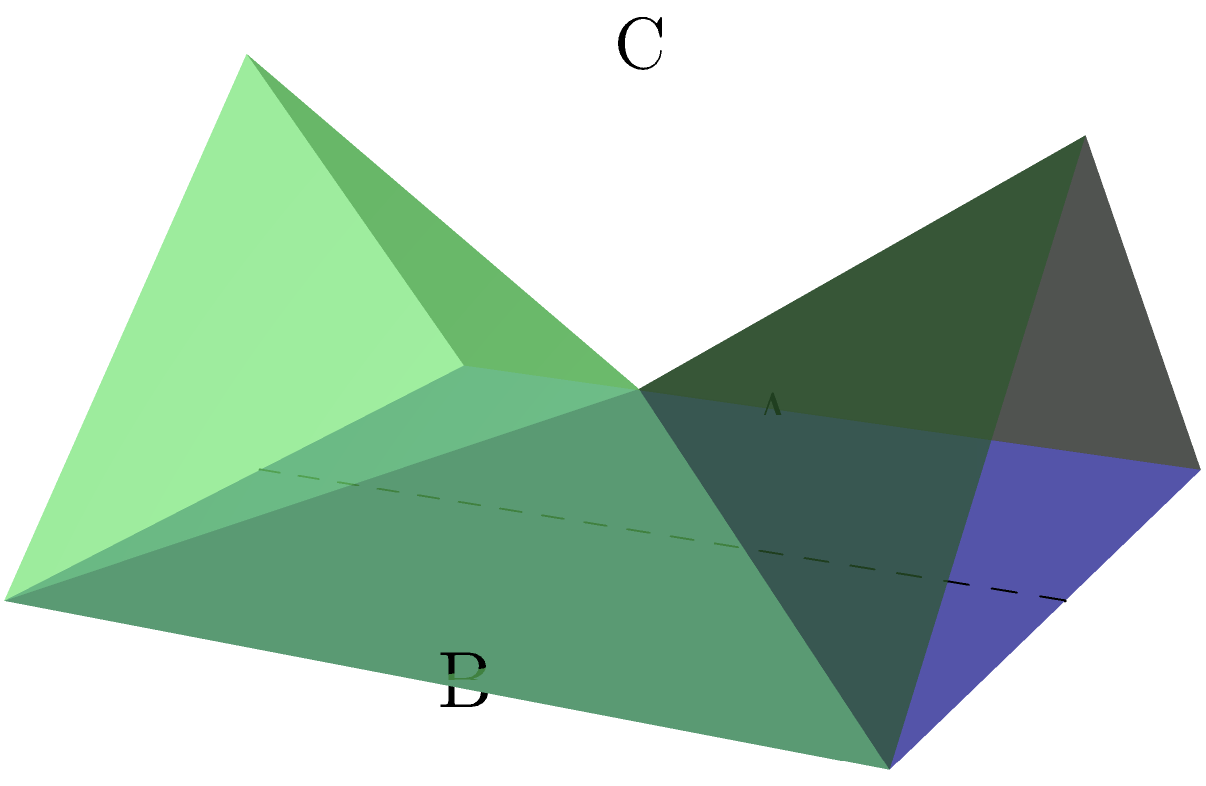In the spirit of unconventional transformations, consider a square sheet of paper with side length 2 units. If you fold it along its vertical midline and then cut a semicircle with diameter equal to the side length of the original square, centered on the fold, what will be the surface area of the resulting 3D shape when unfolded? Express your answer in terms of $\pi$. Let's approach this step-by-step, embracing the abstract nature of the problem:

1) Initially, we have a square with side length 2 units. Its area is $A_{square} = 2^2 = 4$ square units.

2) When we fold the square, we're essentially creating two layers, each 1 unit wide and 2 units long.

3) The semicircle we cut will have a radius of 1 unit (half the side length of the original square).

4) When we unfold the paper, this semicircular cut will create a circular hole in the center of the square.

5) The area of this circular hole is half the area of a full circle:
   $A_{hole} = \frac{1}{2} \pi r^2 = \frac{1}{2} \pi (1)^2 = \frac{\pi}{2}$ square units

6) The surface area of our 3D shape will be the area of the original square minus the area of the hole:
   $A_{3D} = A_{square} - A_{hole} = 4 - \frac{\pi}{2}$ square units

7) To express this in terms of $\pi$, we can write:
   $A_{3D} = 4 - \frac{\pi}{2} = \frac{8 - \pi}{2}$ square units

This transformation creates a shape that's both mathematical and artistic, blending the precision of geometry with the creativity of paper crafting.
Answer: $\frac{8 - \pi}{2}$ square units 